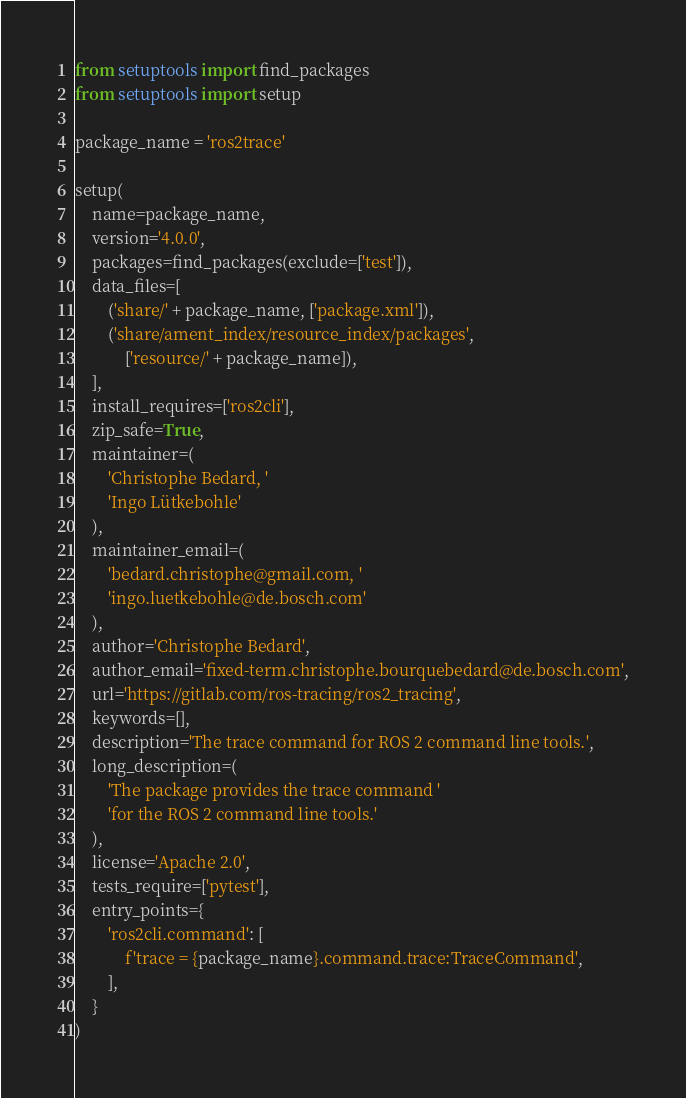Convert code to text. <code><loc_0><loc_0><loc_500><loc_500><_Python_>from setuptools import find_packages
from setuptools import setup

package_name = 'ros2trace'

setup(
    name=package_name,
    version='4.0.0',
    packages=find_packages(exclude=['test']),
    data_files=[
        ('share/' + package_name, ['package.xml']),
        ('share/ament_index/resource_index/packages',
            ['resource/' + package_name]),
    ],
    install_requires=['ros2cli'],
    zip_safe=True,
    maintainer=(
        'Christophe Bedard, '
        'Ingo Lütkebohle'
    ),
    maintainer_email=(
        'bedard.christophe@gmail.com, '
        'ingo.luetkebohle@de.bosch.com'
    ),
    author='Christophe Bedard',
    author_email='fixed-term.christophe.bourquebedard@de.bosch.com',
    url='https://gitlab.com/ros-tracing/ros2_tracing',
    keywords=[],
    description='The trace command for ROS 2 command line tools.',
    long_description=(
        'The package provides the trace command '
        'for the ROS 2 command line tools.'
    ),
    license='Apache 2.0',
    tests_require=['pytest'],
    entry_points={
        'ros2cli.command': [
            f'trace = {package_name}.command.trace:TraceCommand',
        ],
    }
)
</code> 